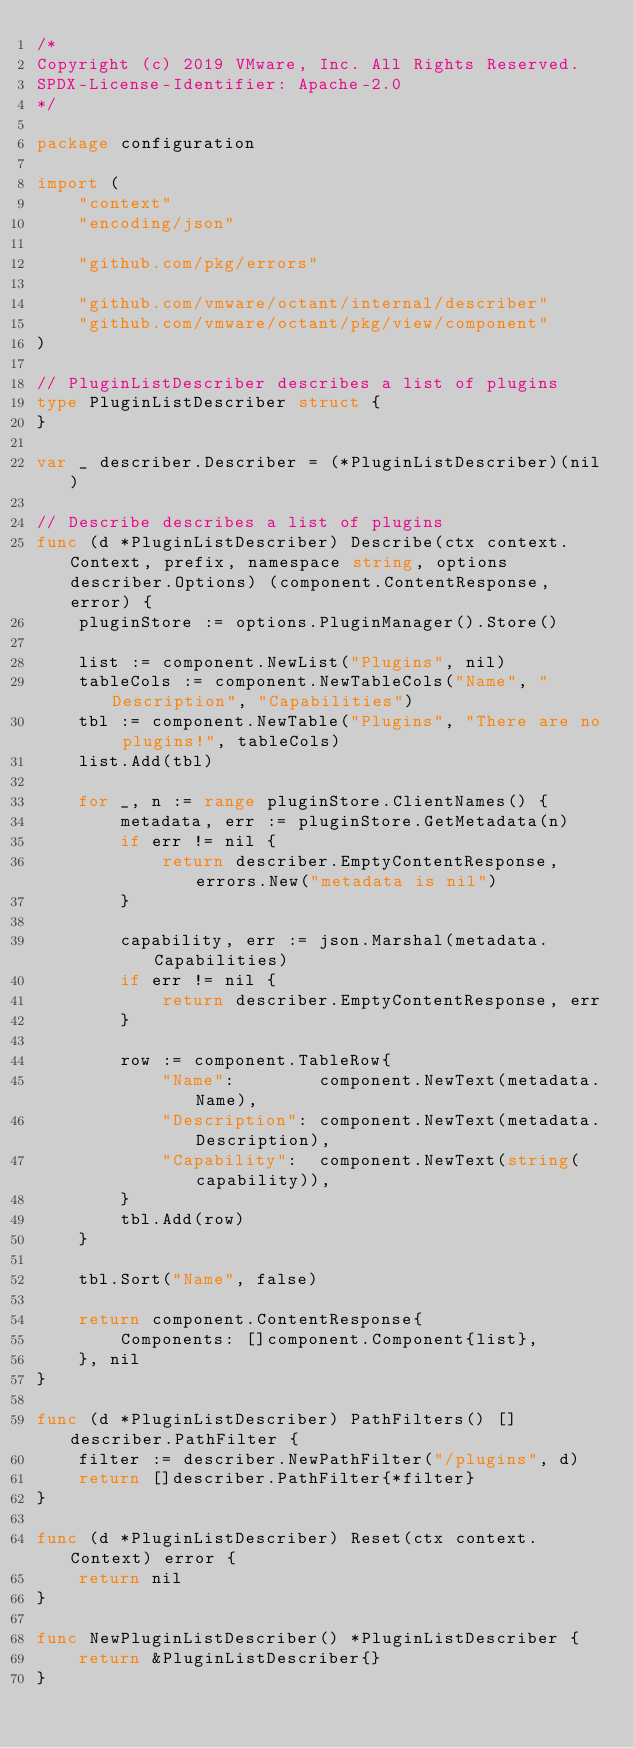Convert code to text. <code><loc_0><loc_0><loc_500><loc_500><_Go_>/*
Copyright (c) 2019 VMware, Inc. All Rights Reserved.
SPDX-License-Identifier: Apache-2.0
*/

package configuration

import (
	"context"
	"encoding/json"

	"github.com/pkg/errors"

	"github.com/vmware/octant/internal/describer"
	"github.com/vmware/octant/pkg/view/component"
)

// PluginListDescriber describes a list of plugins
type PluginListDescriber struct {
}

var _ describer.Describer = (*PluginListDescriber)(nil)

// Describe describes a list of plugins
func (d *PluginListDescriber) Describe(ctx context.Context, prefix, namespace string, options describer.Options) (component.ContentResponse, error) {
	pluginStore := options.PluginManager().Store()

	list := component.NewList("Plugins", nil)
	tableCols := component.NewTableCols("Name", "Description", "Capabilities")
	tbl := component.NewTable("Plugins", "There are no plugins!", tableCols)
	list.Add(tbl)

	for _, n := range pluginStore.ClientNames() {
		metadata, err := pluginStore.GetMetadata(n)
		if err != nil {
			return describer.EmptyContentResponse, errors.New("metadata is nil")
		}

		capability, err := json.Marshal(metadata.Capabilities)
		if err != nil {
			return describer.EmptyContentResponse, err
		}

		row := component.TableRow{
			"Name":        component.NewText(metadata.Name),
			"Description": component.NewText(metadata.Description),
			"Capability":  component.NewText(string(capability)),
		}
		tbl.Add(row)
	}

	tbl.Sort("Name", false)

	return component.ContentResponse{
		Components: []component.Component{list},
	}, nil
}

func (d *PluginListDescriber) PathFilters() []describer.PathFilter {
	filter := describer.NewPathFilter("/plugins", d)
	return []describer.PathFilter{*filter}
}

func (d *PluginListDescriber) Reset(ctx context.Context) error {
	return nil
}

func NewPluginListDescriber() *PluginListDescriber {
	return &PluginListDescriber{}
}
</code> 